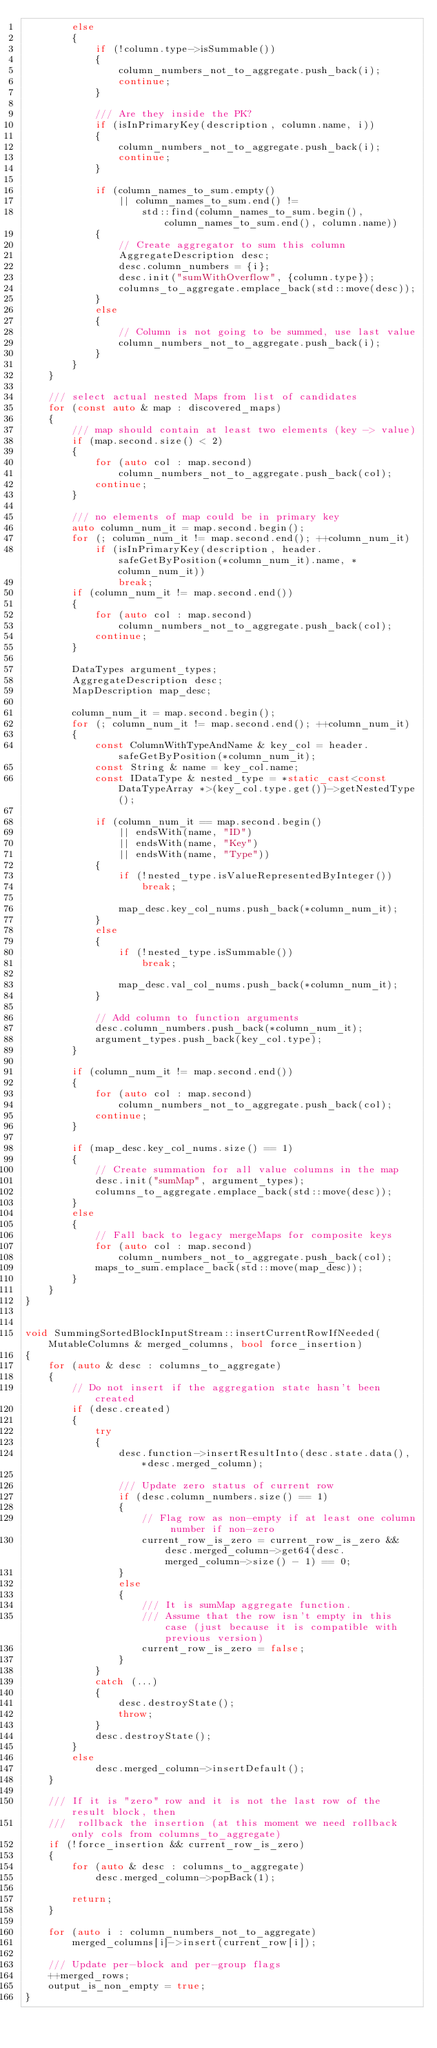Convert code to text. <code><loc_0><loc_0><loc_500><loc_500><_C++_>        else
        {
            if (!column.type->isSummable())
            {
                column_numbers_not_to_aggregate.push_back(i);
                continue;
            }

            /// Are they inside the PK?
            if (isInPrimaryKey(description, column.name, i))
            {
                column_numbers_not_to_aggregate.push_back(i);
                continue;
            }

            if (column_names_to_sum.empty()
                || column_names_to_sum.end() !=
                    std::find(column_names_to_sum.begin(), column_names_to_sum.end(), column.name))
            {
                // Create aggregator to sum this column
                AggregateDescription desc;
                desc.column_numbers = {i};
                desc.init("sumWithOverflow", {column.type});
                columns_to_aggregate.emplace_back(std::move(desc));
            }
            else
            {
                // Column is not going to be summed, use last value
                column_numbers_not_to_aggregate.push_back(i);
            }
        }
    }

    /// select actual nested Maps from list of candidates
    for (const auto & map : discovered_maps)
    {
        /// map should contain at least two elements (key -> value)
        if (map.second.size() < 2)
        {
            for (auto col : map.second)
                column_numbers_not_to_aggregate.push_back(col);
            continue;
        }

        /// no elements of map could be in primary key
        auto column_num_it = map.second.begin();
        for (; column_num_it != map.second.end(); ++column_num_it)
            if (isInPrimaryKey(description, header.safeGetByPosition(*column_num_it).name, *column_num_it))
                break;
        if (column_num_it != map.second.end())
        {
            for (auto col : map.second)
                column_numbers_not_to_aggregate.push_back(col);
            continue;
        }

        DataTypes argument_types;
        AggregateDescription desc;
        MapDescription map_desc;

        column_num_it = map.second.begin();
        for (; column_num_it != map.second.end(); ++column_num_it)
        {
            const ColumnWithTypeAndName & key_col = header.safeGetByPosition(*column_num_it);
            const String & name = key_col.name;
            const IDataType & nested_type = *static_cast<const DataTypeArray *>(key_col.type.get())->getNestedType();

            if (column_num_it == map.second.begin()
                || endsWith(name, "ID")
                || endsWith(name, "Key")
                || endsWith(name, "Type"))
            {
                if (!nested_type.isValueRepresentedByInteger())
                    break;

                map_desc.key_col_nums.push_back(*column_num_it);
            }
            else
            {
                if (!nested_type.isSummable())
                    break;

                map_desc.val_col_nums.push_back(*column_num_it);
            }

            // Add column to function arguments
            desc.column_numbers.push_back(*column_num_it);
            argument_types.push_back(key_col.type);
        }

        if (column_num_it != map.second.end())
        {
            for (auto col : map.second)
                column_numbers_not_to_aggregate.push_back(col);
            continue;
        }

        if (map_desc.key_col_nums.size() == 1)
        {
            // Create summation for all value columns in the map
            desc.init("sumMap", argument_types);
            columns_to_aggregate.emplace_back(std::move(desc));
        }
        else
        {
            // Fall back to legacy mergeMaps for composite keys
            for (auto col : map.second)
                column_numbers_not_to_aggregate.push_back(col);
            maps_to_sum.emplace_back(std::move(map_desc));
        }
    }
}


void SummingSortedBlockInputStream::insertCurrentRowIfNeeded(MutableColumns & merged_columns, bool force_insertion)
{
    for (auto & desc : columns_to_aggregate)
    {
        // Do not insert if the aggregation state hasn't been created
        if (desc.created)
        {
            try
            {
                desc.function->insertResultInto(desc.state.data(), *desc.merged_column);

                /// Update zero status of current row
                if (desc.column_numbers.size() == 1)
                {
                    // Flag row as non-empty if at least one column number if non-zero
                    current_row_is_zero = current_row_is_zero && desc.merged_column->get64(desc.merged_column->size() - 1) == 0;
                }
                else
                {
                    /// It is sumMap aggregate function.
                    /// Assume that the row isn't empty in this case (just because it is compatible with previous version)
                    current_row_is_zero = false;
                }
            }
            catch (...)
            {
                desc.destroyState();
                throw;
            }
            desc.destroyState();
        }
        else
            desc.merged_column->insertDefault();
    }

    /// If it is "zero" row and it is not the last row of the result block, then
    ///  rollback the insertion (at this moment we need rollback only cols from columns_to_aggregate)
    if (!force_insertion && current_row_is_zero)
    {
        for (auto & desc : columns_to_aggregate)
            desc.merged_column->popBack(1);

        return;
    }

    for (auto i : column_numbers_not_to_aggregate)
        merged_columns[i]->insert(current_row[i]);

    /// Update per-block and per-group flags
    ++merged_rows;
    output_is_non_empty = true;
}

</code> 